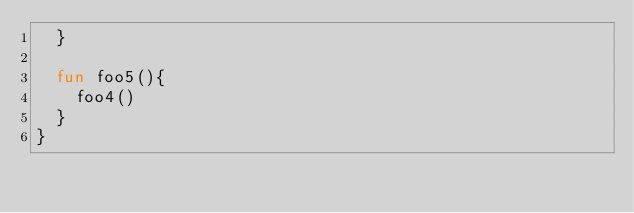<code> <loc_0><loc_0><loc_500><loc_500><_Kotlin_>  }

  fun foo5(){
    foo4()
  }
}</code> 